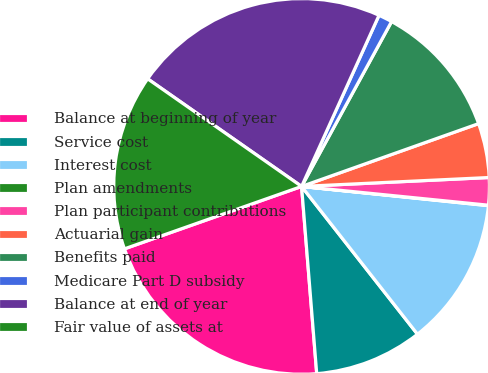Convert chart. <chart><loc_0><loc_0><loc_500><loc_500><pie_chart><fcel>Balance at beginning of year<fcel>Service cost<fcel>Interest cost<fcel>Plan amendments<fcel>Plan participant contributions<fcel>Actuarial gain<fcel>Benefits paid<fcel>Medicare Part D subsidy<fcel>Balance at end of year<fcel>Fair value of assets at<nl><fcel>20.89%<fcel>9.3%<fcel>12.78%<fcel>0.04%<fcel>2.35%<fcel>4.67%<fcel>11.62%<fcel>1.19%<fcel>22.05%<fcel>15.1%<nl></chart> 